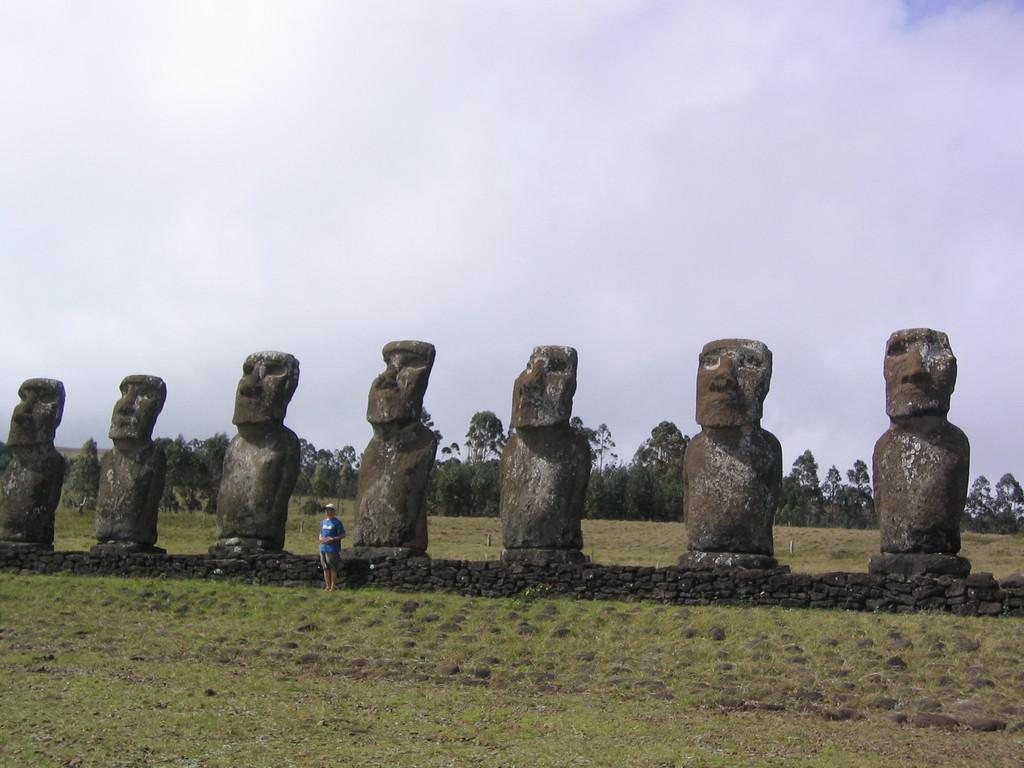What type of landscape is depicted in the image? There is a grassland in the image. What can be seen in the background of the grassland? There are sculptures in the background of the image. Who is present in the image? A man is standing near the sculptures. What other natural elements are visible in the image? There are trees in the image. What is visible above the grassland and trees? The sky is visible in the image. What type of bulb is growing on the grassland in the image? There is no bulb growing on the grassland in the image. Can you tell me how many berries are on the trees in the image? There is no mention of berries on the trees in the image; only trees are mentioned. 